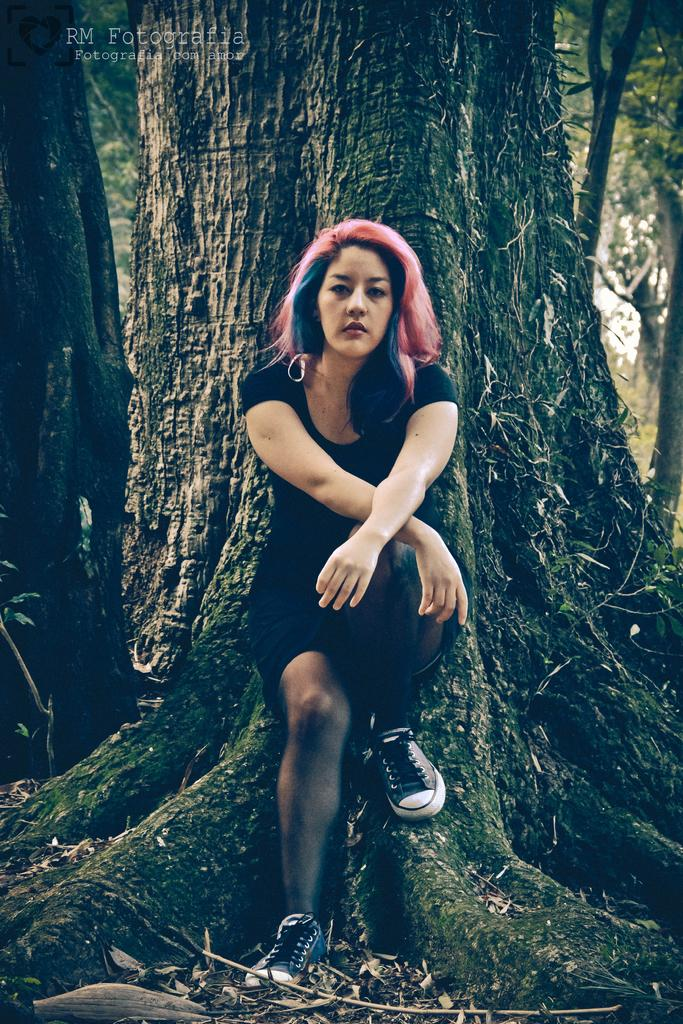Who is present in the image? There is a woman in the image. What can be seen in the background of the image? There are trees in the background of the image. Is there any text visible in the image? Yes, there is some text visible in the top left corner of the image. How many bottles can be seen in the image? There are no bottles present in the image. What time is displayed on the clocks in the image? There are no clocks present in the image. 